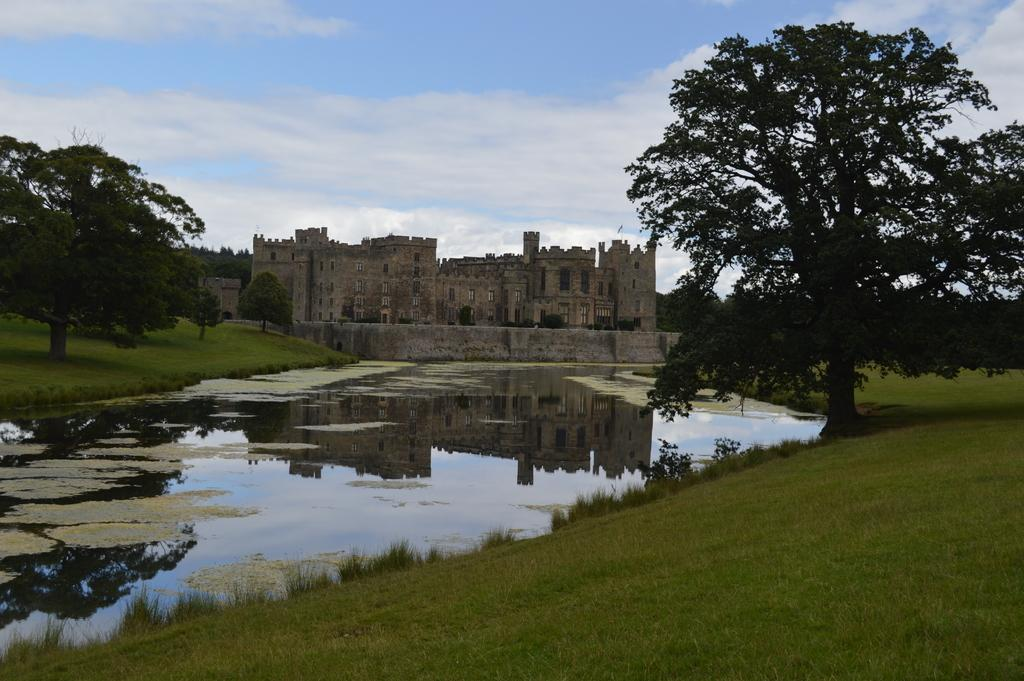What is the main feature of the image? The main feature of the image is water with algae. What type of vegetation can be seen at the bottom of the image? There is grass at the bottom of the image. What other types of vegetation are present in the image? There are plants and trees in the image. What is visible in the background of the image? The background of the image includes a sky and a fort with walls. What architectural feature can be seen on the fort? There are windows visible on the fort. What type of exchange is taking place between the cakes in the image? There are no cakes present in the image; it features water with algae, grass, plants, trees, a sky, and a fort with walls. What type of machine can be seen operating in the background of the image? There is no machine present in the image; it features water with algae, grass, plants, trees, a sky, and a fort with walls. 